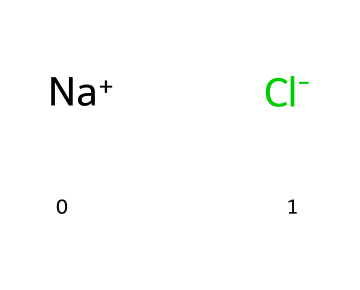What are the constituent atoms of this compound? The SMILES representation indicates two different atoms: sodium (Na) and chlorine (Cl). These are the only atoms present in the chemical structure.
Answer: sodium and chlorine How many atoms are in this structure? The representation shows one sodium atom and one chlorine atom. Thus, the total number of atoms is two.
Answer: 2 What type of solid structure does sodium chloride form? Sodium chloride forms a crystalline structure, where the arrangement of ions is in a repeating three-dimensional lattice.
Answer: crystalline What is the coordination number of sodium ions in sodium chloride? In sodium chloride, each sodium ion is surrounded by six chloride ions and vice versa, leading to a coordination number of six.
Answer: 6 What is the predominant type of bond in sodium chloride? The bond formed between sodium and chlorine in sodium chloride is ionic, as sodium donates an electron to chlorine, resulting in charged ions.
Answer: ionic What effect does the arrangement of atoms have on the melting point of sodium chloride? The regular, repeating ionic arrangement leads to strong electrostatic forces between oppositely charged ions, contributing to a high melting point (about 801°C).
Answer: high What is the overall charge of a sodium chloride crystal? In a sodium chloride crystal, the overall charge is neutral because the positive charge of Na+ balances with the negative charge of Cl-.
Answer: neutral 